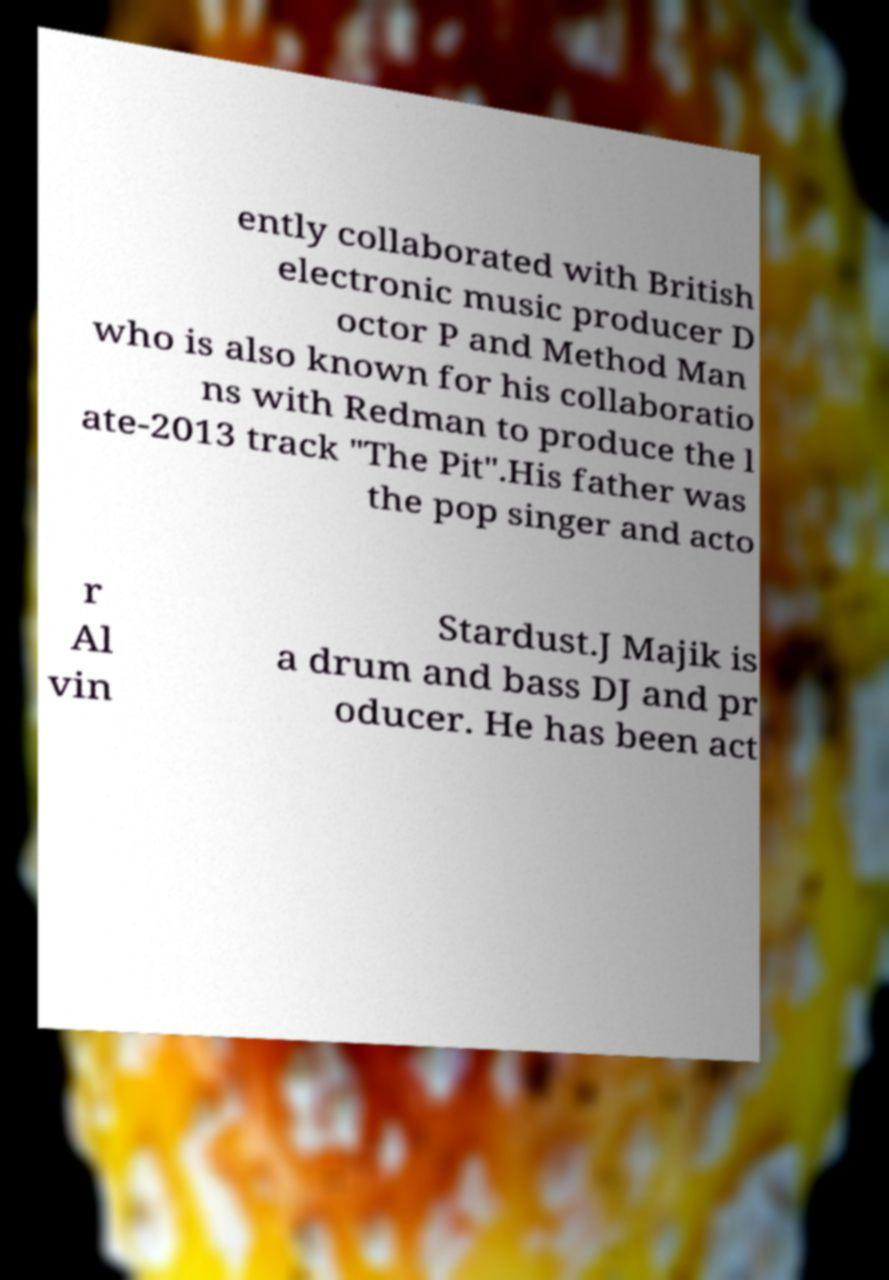Please identify and transcribe the text found in this image. ently collaborated with British electronic music producer D octor P and Method Man who is also known for his collaboratio ns with Redman to produce the l ate-2013 track "The Pit".His father was the pop singer and acto r Al vin Stardust.J Majik is a drum and bass DJ and pr oducer. He has been act 